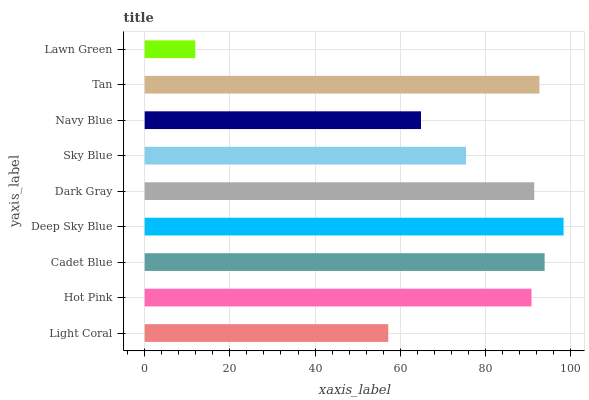Is Lawn Green the minimum?
Answer yes or no. Yes. Is Deep Sky Blue the maximum?
Answer yes or no. Yes. Is Hot Pink the minimum?
Answer yes or no. No. Is Hot Pink the maximum?
Answer yes or no. No. Is Hot Pink greater than Light Coral?
Answer yes or no. Yes. Is Light Coral less than Hot Pink?
Answer yes or no. Yes. Is Light Coral greater than Hot Pink?
Answer yes or no. No. Is Hot Pink less than Light Coral?
Answer yes or no. No. Is Hot Pink the high median?
Answer yes or no. Yes. Is Hot Pink the low median?
Answer yes or no. Yes. Is Light Coral the high median?
Answer yes or no. No. Is Dark Gray the low median?
Answer yes or no. No. 